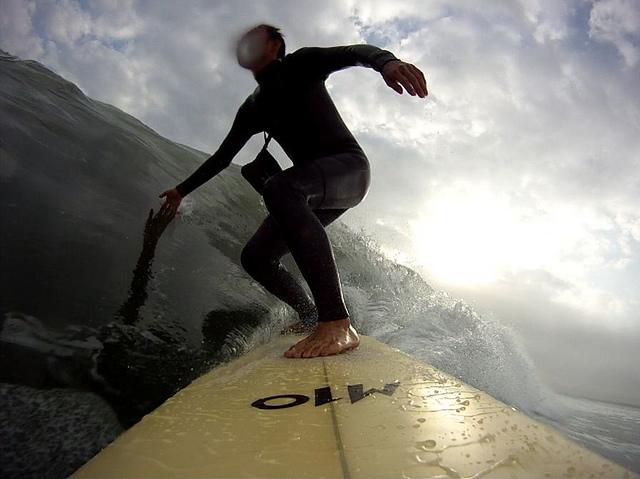What number is on the board?
Short answer required. 10. What color is the surfboards logo?
Write a very short answer. Black. Is the man stuck on the surfboard?
Quick response, please. No. What color is the surfboard?
Answer briefly. Yellow. What is the man wearing?
Write a very short answer. Wetsuit. Is this an image from a viewpoint close to the surfer?
Concise answer only. Yes. 